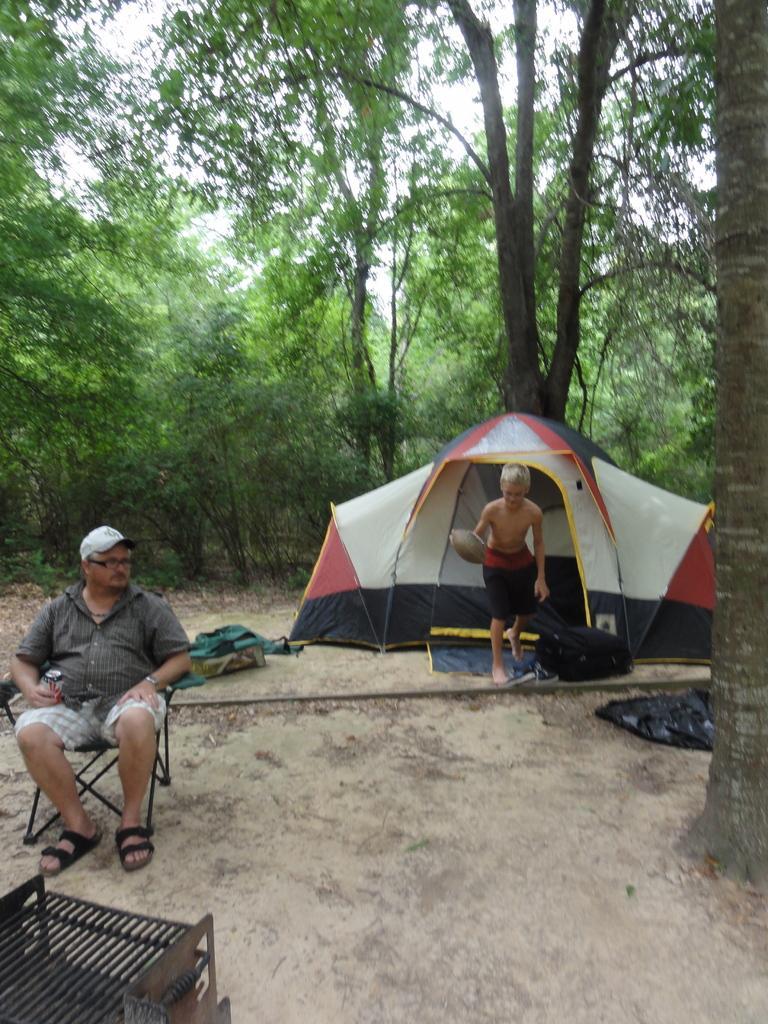Describe this image in one or two sentences. In this image we can see two person's, a person wearing dress and cap sitting on a chair and in the background of the image we can see another person wearing black color short standing near the camping tent, we can see some bags which are on ground and we can see some trees, clear sky. 